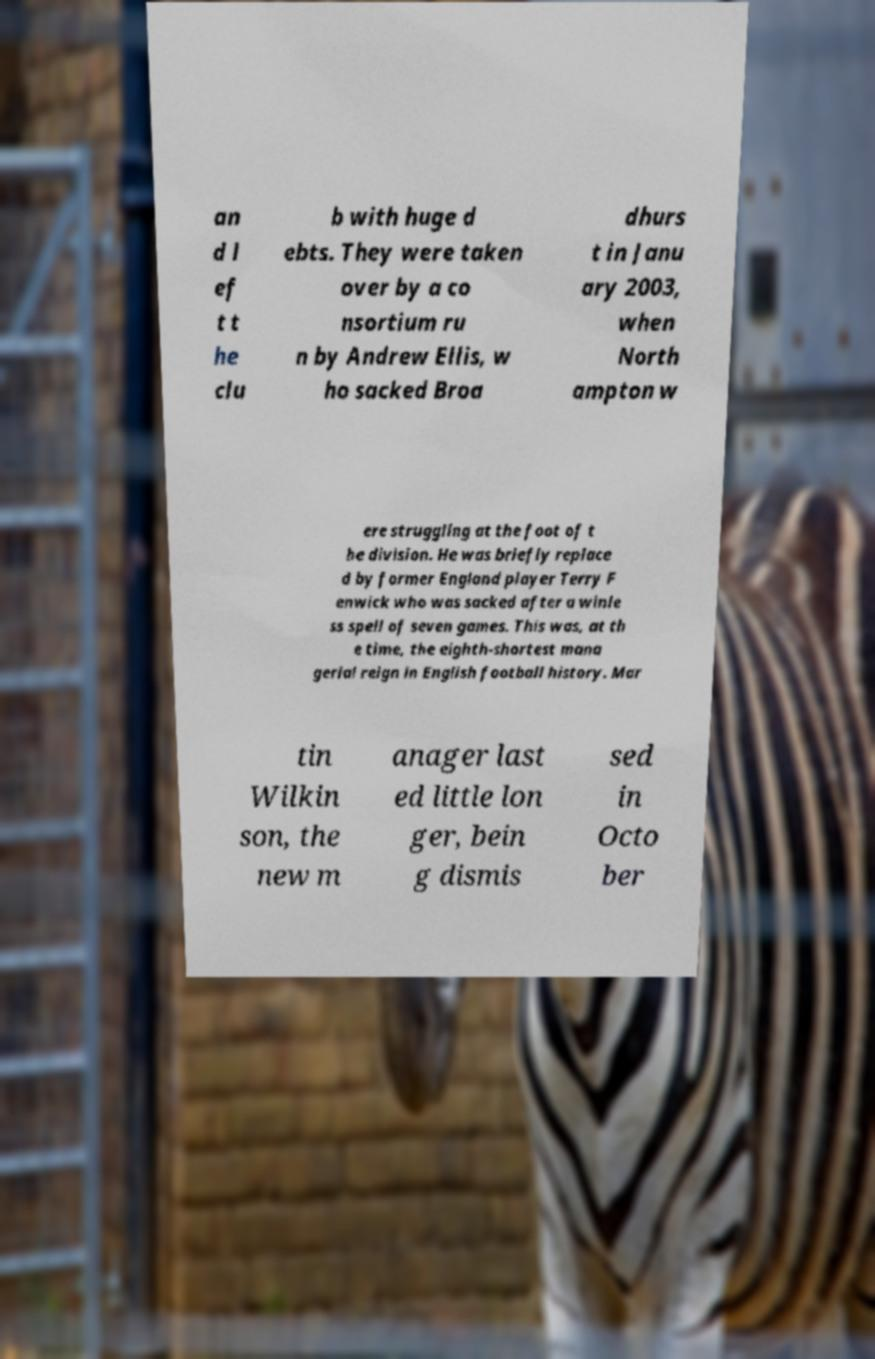What messages or text are displayed in this image? I need them in a readable, typed format. an d l ef t t he clu b with huge d ebts. They were taken over by a co nsortium ru n by Andrew Ellis, w ho sacked Broa dhurs t in Janu ary 2003, when North ampton w ere struggling at the foot of t he division. He was briefly replace d by former England player Terry F enwick who was sacked after a winle ss spell of seven games. This was, at th e time, the eighth-shortest mana gerial reign in English football history. Mar tin Wilkin son, the new m anager last ed little lon ger, bein g dismis sed in Octo ber 